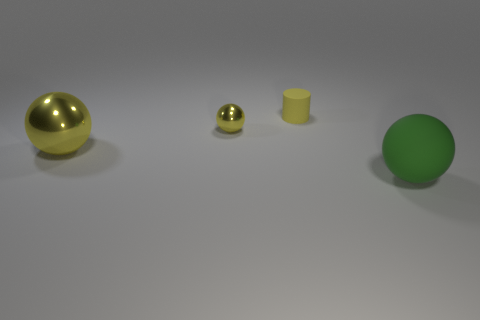Subtract all big yellow shiny balls. How many balls are left? 2 Subtract all yellow spheres. How many spheres are left? 1 Subtract all spheres. How many objects are left? 1 Add 3 purple metal cylinders. How many objects exist? 7 Subtract 1 cylinders. How many cylinders are left? 0 Subtract all large green rubber objects. Subtract all brown matte cubes. How many objects are left? 3 Add 1 balls. How many balls are left? 4 Add 2 purple balls. How many purple balls exist? 2 Subtract 0 gray cylinders. How many objects are left? 4 Subtract all brown spheres. Subtract all green cubes. How many spheres are left? 3 